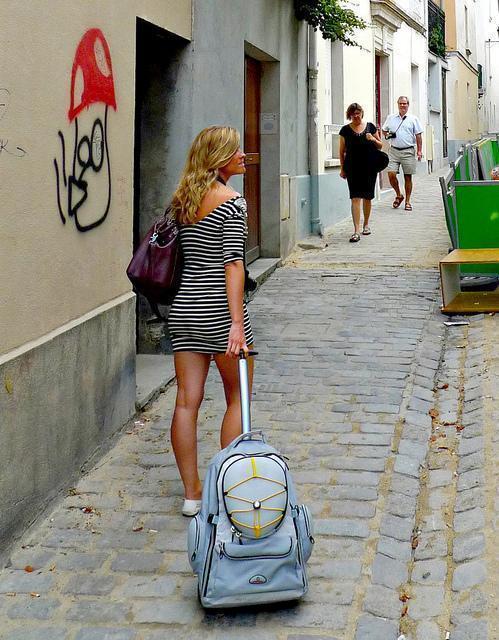Where might the lady on the sidewalk be going?
Select the accurate answer and provide explanation: 'Answer: answer
Rationale: rationale.'
Options: Vacation, protest, work, sales job. Answer: vacation.
Rationale: She has a suitcase with her which is not usually brought to work, jobs, or protests. 